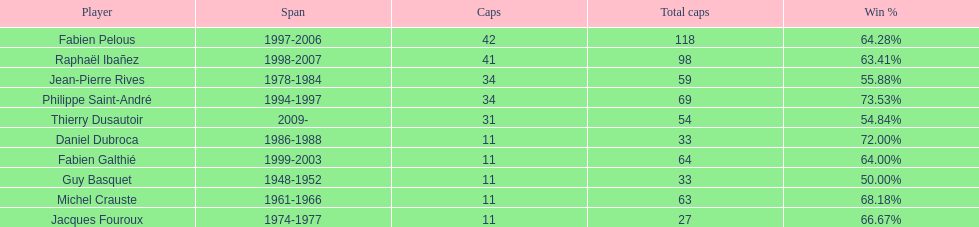Only player to serve as captain from 1998-2007 Raphaël Ibañez. Write the full table. {'header': ['Player', 'Span', 'Caps', 'Total caps', 'Win\xa0%'], 'rows': [['Fabien Pelous', '1997-2006', '42', '118', '64.28%'], ['Raphaël Ibañez', '1998-2007', '41', '98', '63.41%'], ['Jean-Pierre Rives', '1978-1984', '34', '59', '55.88%'], ['Philippe Saint-André', '1994-1997', '34', '69', '73.53%'], ['Thierry Dusautoir', '2009-', '31', '54', '54.84%'], ['Daniel Dubroca', '1986-1988', '11', '33', '72.00%'], ['Fabien Galthié', '1999-2003', '11', '64', '64.00%'], ['Guy Basquet', '1948-1952', '11', '33', '50.00%'], ['Michel Crauste', '1961-1966', '11', '63', '68.18%'], ['Jacques Fouroux', '1974-1977', '11', '27', '66.67%']]} 